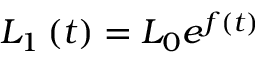<formula> <loc_0><loc_0><loc_500><loc_500>L _ { 1 } \left ( t \right ) = L _ { 0 } e ^ { f \left ( t \right ) }</formula> 